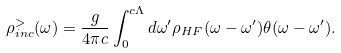Convert formula to latex. <formula><loc_0><loc_0><loc_500><loc_500>\rho _ { i n c } ^ { > } ( \omega ) = \frac { g } { 4 \pi c } \int _ { 0 } ^ { c \Lambda } d \omega ^ { \prime } \rho _ { H F } ( \omega - \omega ^ { \prime } ) \theta ( \omega - \omega ^ { \prime } ) .</formula> 